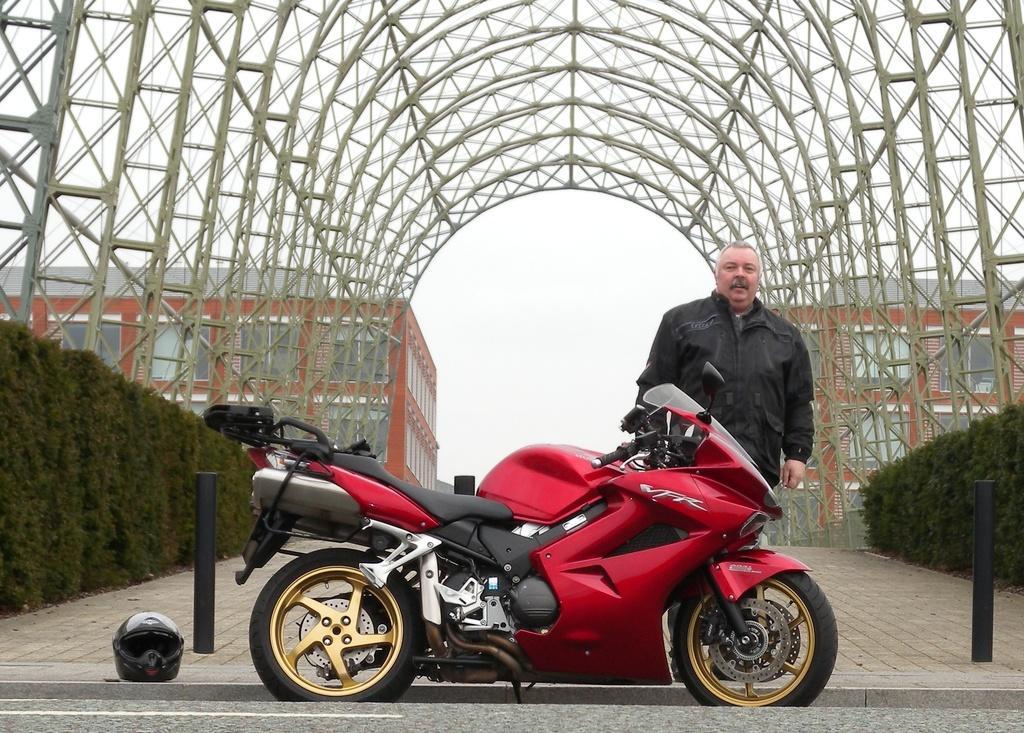Could you give a brief overview of what you see in this image? In this image there is a bike and there is a person standing. On the ground there is a helmet. In the background there are plants, buildings and there is a metal arch and the sky is cloudy. 